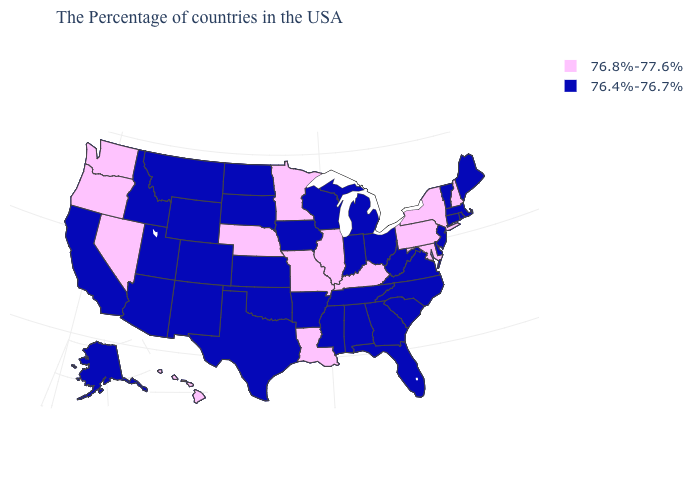How many symbols are there in the legend?
Write a very short answer. 2. Which states have the highest value in the USA?
Be succinct. New Hampshire, New York, Maryland, Pennsylvania, Kentucky, Illinois, Louisiana, Missouri, Minnesota, Nebraska, Nevada, Washington, Oregon, Hawaii. What is the value of Kentucky?
Keep it brief. 76.8%-77.6%. What is the value of Georgia?
Keep it brief. 76.4%-76.7%. What is the value of Indiana?
Give a very brief answer. 76.4%-76.7%. What is the lowest value in the South?
Quick response, please. 76.4%-76.7%. Is the legend a continuous bar?
Short answer required. No. Name the states that have a value in the range 76.8%-77.6%?
Concise answer only. New Hampshire, New York, Maryland, Pennsylvania, Kentucky, Illinois, Louisiana, Missouri, Minnesota, Nebraska, Nevada, Washington, Oregon, Hawaii. What is the value of Nebraska?
Write a very short answer. 76.8%-77.6%. Which states have the lowest value in the USA?
Keep it brief. Maine, Massachusetts, Rhode Island, Vermont, Connecticut, New Jersey, Delaware, Virginia, North Carolina, South Carolina, West Virginia, Ohio, Florida, Georgia, Michigan, Indiana, Alabama, Tennessee, Wisconsin, Mississippi, Arkansas, Iowa, Kansas, Oklahoma, Texas, South Dakota, North Dakota, Wyoming, Colorado, New Mexico, Utah, Montana, Arizona, Idaho, California, Alaska. What is the highest value in states that border North Carolina?
Short answer required. 76.4%-76.7%. What is the lowest value in the USA?
Concise answer only. 76.4%-76.7%. Does the first symbol in the legend represent the smallest category?
Keep it brief. No. What is the lowest value in the USA?
Short answer required. 76.4%-76.7%. 